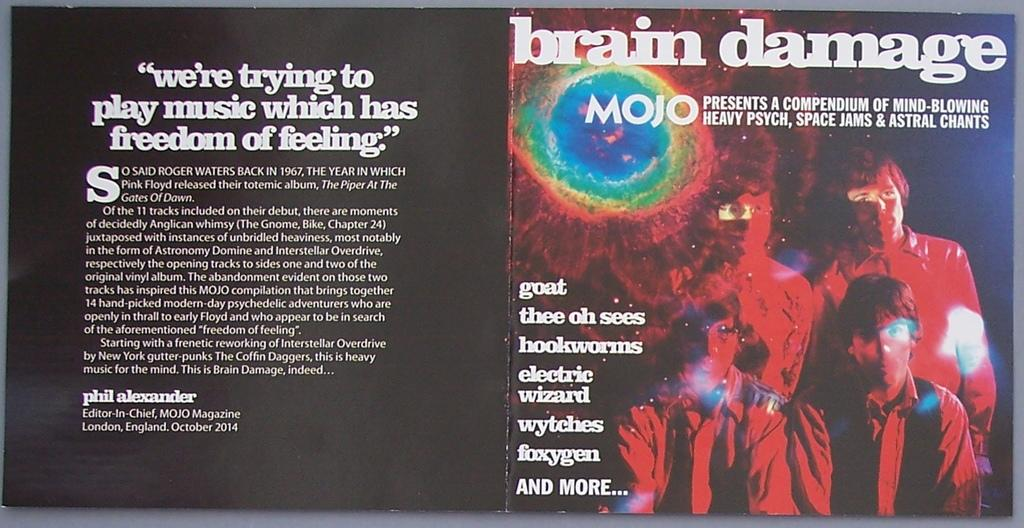<image>
Present a compact description of the photo's key features. A collection of music from Mojo is called Brain Damage. 